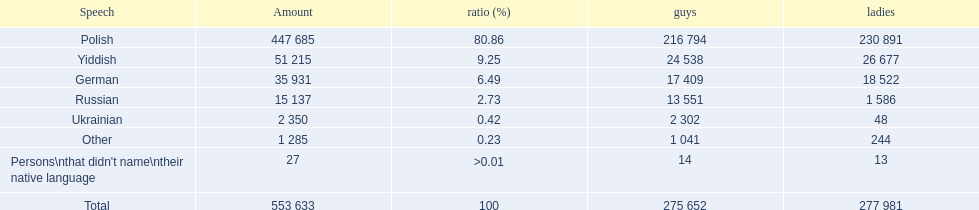What are the percentages of people? 80.86, 9.25, 6.49, 2.73, 0.42, 0.23, >0.01. Which language is .42%? Ukrainian. 